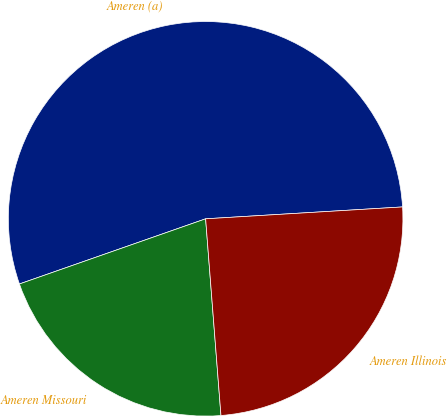<chart> <loc_0><loc_0><loc_500><loc_500><pie_chart><fcel>Ameren (a)<fcel>Ameren Missouri<fcel>Ameren Illinois<nl><fcel>54.4%<fcel>20.88%<fcel>24.72%<nl></chart> 